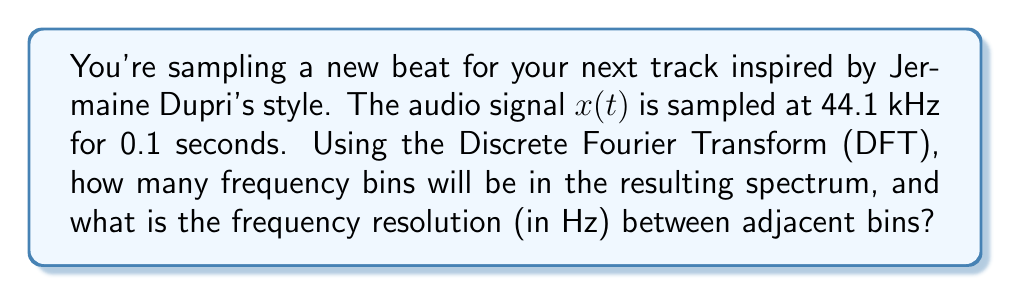Teach me how to tackle this problem. Let's approach this step-by-step:

1) First, we need to calculate the total number of samples (N):
   Sample rate = 44.1 kHz = 44,100 Hz
   Duration = 0.1 seconds
   $N = 44,100 \text{ Hz} \times 0.1 \text{ s} = 4,410 \text{ samples}$

2) In the DFT, the number of frequency bins is equal to the number of samples. So there will be 4,410 bins.

3) To calculate the frequency resolution, we use the formula:
   $\Delta f = \frac{f_s}{N}$

   Where:
   $\Delta f$ is the frequency resolution
   $f_s$ is the sampling frequency
   $N$ is the number of samples

4) Plugging in our values:
   $\Delta f = \frac{44,100 \text{ Hz}}{4,410} = 10 \text{ Hz}$

Therefore, the frequency resolution between adjacent bins is 10 Hz.
Answer: 4,410 bins; 10 Hz resolution 